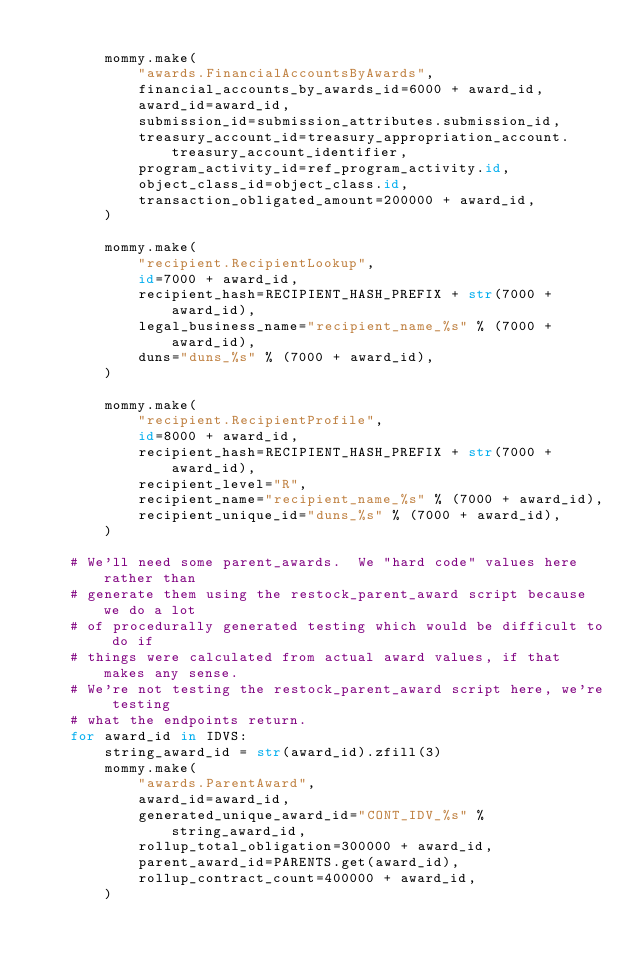<code> <loc_0><loc_0><loc_500><loc_500><_Python_>
        mommy.make(
            "awards.FinancialAccountsByAwards",
            financial_accounts_by_awards_id=6000 + award_id,
            award_id=award_id,
            submission_id=submission_attributes.submission_id,
            treasury_account_id=treasury_appropriation_account.treasury_account_identifier,
            program_activity_id=ref_program_activity.id,
            object_class_id=object_class.id,
            transaction_obligated_amount=200000 + award_id,
        )

        mommy.make(
            "recipient.RecipientLookup",
            id=7000 + award_id,
            recipient_hash=RECIPIENT_HASH_PREFIX + str(7000 + award_id),
            legal_business_name="recipient_name_%s" % (7000 + award_id),
            duns="duns_%s" % (7000 + award_id),
        )

        mommy.make(
            "recipient.RecipientProfile",
            id=8000 + award_id,
            recipient_hash=RECIPIENT_HASH_PREFIX + str(7000 + award_id),
            recipient_level="R",
            recipient_name="recipient_name_%s" % (7000 + award_id),
            recipient_unique_id="duns_%s" % (7000 + award_id),
        )

    # We'll need some parent_awards.  We "hard code" values here rather than
    # generate them using the restock_parent_award script because we do a lot
    # of procedurally generated testing which would be difficult to do if
    # things were calculated from actual award values, if that makes any sense.
    # We're not testing the restock_parent_award script here, we're testing
    # what the endpoints return.
    for award_id in IDVS:
        string_award_id = str(award_id).zfill(3)
        mommy.make(
            "awards.ParentAward",
            award_id=award_id,
            generated_unique_award_id="CONT_IDV_%s" % string_award_id,
            rollup_total_obligation=300000 + award_id,
            parent_award_id=PARENTS.get(award_id),
            rollup_contract_count=400000 + award_id,
        )
</code> 